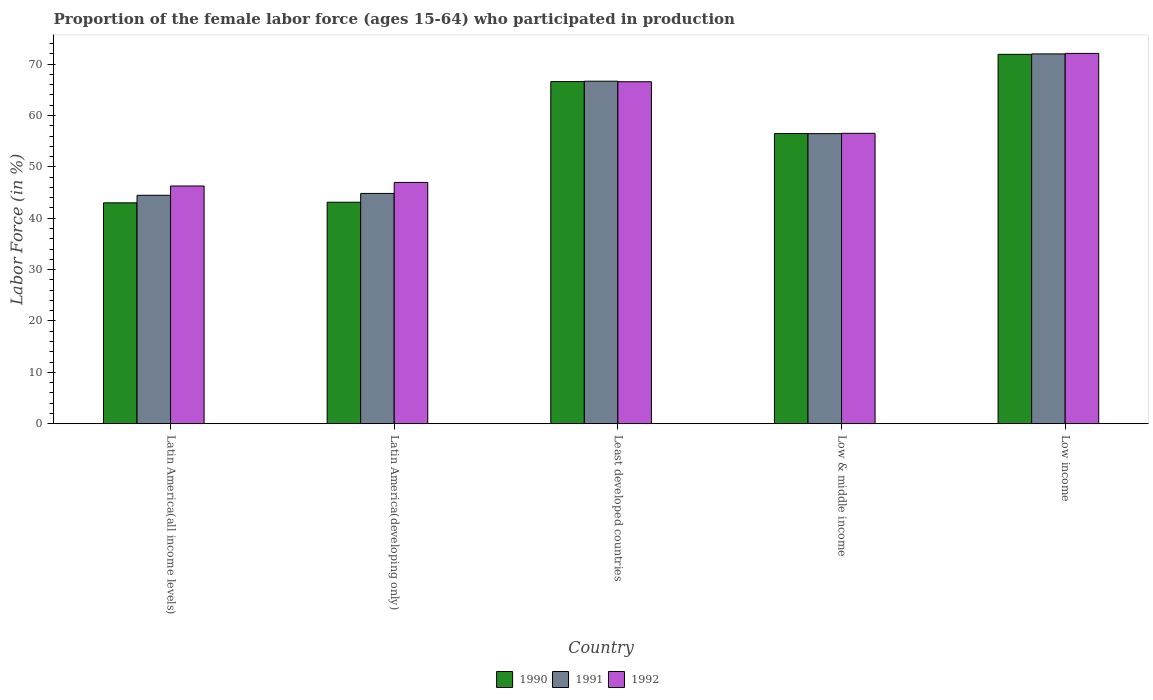How many different coloured bars are there?
Provide a succinct answer. 3. How many bars are there on the 3rd tick from the right?
Give a very brief answer. 3. What is the label of the 1st group of bars from the left?
Your answer should be very brief. Latin America(all income levels). What is the proportion of the female labor force who participated in production in 1991 in Low income?
Your answer should be very brief. 71.99. Across all countries, what is the maximum proportion of the female labor force who participated in production in 1991?
Offer a terse response. 71.99. Across all countries, what is the minimum proportion of the female labor force who participated in production in 1990?
Your answer should be compact. 43. In which country was the proportion of the female labor force who participated in production in 1992 minimum?
Make the answer very short. Latin America(all income levels). What is the total proportion of the female labor force who participated in production in 1991 in the graph?
Your answer should be very brief. 284.44. What is the difference between the proportion of the female labor force who participated in production in 1991 in Least developed countries and that in Low income?
Make the answer very short. -5.31. What is the difference between the proportion of the female labor force who participated in production in 1991 in Latin America(all income levels) and the proportion of the female labor force who participated in production in 1990 in Least developed countries?
Your answer should be very brief. -22.14. What is the average proportion of the female labor force who participated in production in 1990 per country?
Give a very brief answer. 56.22. What is the difference between the proportion of the female labor force who participated in production of/in 1992 and proportion of the female labor force who participated in production of/in 1991 in Least developed countries?
Offer a terse response. -0.1. What is the ratio of the proportion of the female labor force who participated in production in 1992 in Least developed countries to that in Low & middle income?
Provide a succinct answer. 1.18. Is the difference between the proportion of the female labor force who participated in production in 1992 in Latin America(all income levels) and Latin America(developing only) greater than the difference between the proportion of the female labor force who participated in production in 1991 in Latin America(all income levels) and Latin America(developing only)?
Provide a short and direct response. No. What is the difference between the highest and the second highest proportion of the female labor force who participated in production in 1990?
Keep it short and to the point. -10.12. What is the difference between the highest and the lowest proportion of the female labor force who participated in production in 1992?
Make the answer very short. 25.81. Is the sum of the proportion of the female labor force who participated in production in 1992 in Latin America(all income levels) and Least developed countries greater than the maximum proportion of the female labor force who participated in production in 1991 across all countries?
Your response must be concise. Yes. What does the 2nd bar from the right in Low income represents?
Give a very brief answer. 1991. Is it the case that in every country, the sum of the proportion of the female labor force who participated in production in 1992 and proportion of the female labor force who participated in production in 1990 is greater than the proportion of the female labor force who participated in production in 1991?
Provide a short and direct response. Yes. How many bars are there?
Keep it short and to the point. 15. How many countries are there in the graph?
Provide a short and direct response. 5. What is the difference between two consecutive major ticks on the Y-axis?
Your answer should be compact. 10. Does the graph contain any zero values?
Your answer should be compact. No. What is the title of the graph?
Ensure brevity in your answer.  Proportion of the female labor force (ages 15-64) who participated in production. What is the label or title of the X-axis?
Keep it short and to the point. Country. What is the label or title of the Y-axis?
Keep it short and to the point. Labor Force (in %). What is the Labor Force (in %) in 1990 in Latin America(all income levels)?
Provide a short and direct response. 43. What is the Labor Force (in %) of 1991 in Latin America(all income levels)?
Provide a succinct answer. 44.47. What is the Labor Force (in %) of 1992 in Latin America(all income levels)?
Provide a succinct answer. 46.28. What is the Labor Force (in %) of 1990 in Latin America(developing only)?
Offer a very short reply. 43.12. What is the Labor Force (in %) in 1991 in Latin America(developing only)?
Your answer should be compact. 44.83. What is the Labor Force (in %) of 1992 in Latin America(developing only)?
Your response must be concise. 46.97. What is the Labor Force (in %) of 1990 in Least developed countries?
Make the answer very short. 66.61. What is the Labor Force (in %) of 1991 in Least developed countries?
Offer a very short reply. 66.68. What is the Labor Force (in %) in 1992 in Least developed countries?
Provide a short and direct response. 66.57. What is the Labor Force (in %) of 1990 in Low & middle income?
Your answer should be very brief. 56.48. What is the Labor Force (in %) in 1991 in Low & middle income?
Your response must be concise. 56.47. What is the Labor Force (in %) in 1992 in Low & middle income?
Ensure brevity in your answer.  56.53. What is the Labor Force (in %) of 1990 in Low income?
Provide a short and direct response. 71.9. What is the Labor Force (in %) in 1991 in Low income?
Provide a succinct answer. 71.99. What is the Labor Force (in %) of 1992 in Low income?
Your response must be concise. 72.09. Across all countries, what is the maximum Labor Force (in %) in 1990?
Make the answer very short. 71.9. Across all countries, what is the maximum Labor Force (in %) in 1991?
Offer a very short reply. 71.99. Across all countries, what is the maximum Labor Force (in %) in 1992?
Your answer should be very brief. 72.09. Across all countries, what is the minimum Labor Force (in %) of 1990?
Give a very brief answer. 43. Across all countries, what is the minimum Labor Force (in %) of 1991?
Give a very brief answer. 44.47. Across all countries, what is the minimum Labor Force (in %) in 1992?
Your answer should be very brief. 46.28. What is the total Labor Force (in %) in 1990 in the graph?
Make the answer very short. 281.12. What is the total Labor Force (in %) in 1991 in the graph?
Provide a short and direct response. 284.44. What is the total Labor Force (in %) of 1992 in the graph?
Provide a succinct answer. 288.44. What is the difference between the Labor Force (in %) of 1990 in Latin America(all income levels) and that in Latin America(developing only)?
Keep it short and to the point. -0.12. What is the difference between the Labor Force (in %) of 1991 in Latin America(all income levels) and that in Latin America(developing only)?
Your response must be concise. -0.36. What is the difference between the Labor Force (in %) of 1992 in Latin America(all income levels) and that in Latin America(developing only)?
Keep it short and to the point. -0.69. What is the difference between the Labor Force (in %) of 1990 in Latin America(all income levels) and that in Least developed countries?
Offer a very short reply. -23.61. What is the difference between the Labor Force (in %) of 1991 in Latin America(all income levels) and that in Least developed countries?
Ensure brevity in your answer.  -22.21. What is the difference between the Labor Force (in %) of 1992 in Latin America(all income levels) and that in Least developed countries?
Give a very brief answer. -20.29. What is the difference between the Labor Force (in %) in 1990 in Latin America(all income levels) and that in Low & middle income?
Your answer should be compact. -13.48. What is the difference between the Labor Force (in %) of 1991 in Latin America(all income levels) and that in Low & middle income?
Provide a succinct answer. -12. What is the difference between the Labor Force (in %) of 1992 in Latin America(all income levels) and that in Low & middle income?
Offer a terse response. -10.25. What is the difference between the Labor Force (in %) of 1990 in Latin America(all income levels) and that in Low income?
Keep it short and to the point. -28.9. What is the difference between the Labor Force (in %) in 1991 in Latin America(all income levels) and that in Low income?
Offer a terse response. -27.52. What is the difference between the Labor Force (in %) in 1992 in Latin America(all income levels) and that in Low income?
Provide a succinct answer. -25.81. What is the difference between the Labor Force (in %) in 1990 in Latin America(developing only) and that in Least developed countries?
Your answer should be very brief. -23.49. What is the difference between the Labor Force (in %) in 1991 in Latin America(developing only) and that in Least developed countries?
Keep it short and to the point. -21.85. What is the difference between the Labor Force (in %) in 1992 in Latin America(developing only) and that in Least developed countries?
Provide a short and direct response. -19.6. What is the difference between the Labor Force (in %) of 1990 in Latin America(developing only) and that in Low & middle income?
Offer a terse response. -13.36. What is the difference between the Labor Force (in %) of 1991 in Latin America(developing only) and that in Low & middle income?
Offer a very short reply. -11.64. What is the difference between the Labor Force (in %) in 1992 in Latin America(developing only) and that in Low & middle income?
Offer a very short reply. -9.56. What is the difference between the Labor Force (in %) in 1990 in Latin America(developing only) and that in Low income?
Give a very brief answer. -28.78. What is the difference between the Labor Force (in %) in 1991 in Latin America(developing only) and that in Low income?
Your answer should be very brief. -27.16. What is the difference between the Labor Force (in %) in 1992 in Latin America(developing only) and that in Low income?
Ensure brevity in your answer.  -25.12. What is the difference between the Labor Force (in %) of 1990 in Least developed countries and that in Low & middle income?
Give a very brief answer. 10.12. What is the difference between the Labor Force (in %) of 1991 in Least developed countries and that in Low & middle income?
Keep it short and to the point. 10.21. What is the difference between the Labor Force (in %) in 1992 in Least developed countries and that in Low & middle income?
Give a very brief answer. 10.04. What is the difference between the Labor Force (in %) in 1990 in Least developed countries and that in Low income?
Make the answer very short. -5.3. What is the difference between the Labor Force (in %) of 1991 in Least developed countries and that in Low income?
Provide a succinct answer. -5.31. What is the difference between the Labor Force (in %) in 1992 in Least developed countries and that in Low income?
Your answer should be compact. -5.52. What is the difference between the Labor Force (in %) of 1990 in Low & middle income and that in Low income?
Your response must be concise. -15.42. What is the difference between the Labor Force (in %) of 1991 in Low & middle income and that in Low income?
Offer a very short reply. -15.52. What is the difference between the Labor Force (in %) in 1992 in Low & middle income and that in Low income?
Your response must be concise. -15.56. What is the difference between the Labor Force (in %) of 1990 in Latin America(all income levels) and the Labor Force (in %) of 1991 in Latin America(developing only)?
Your answer should be compact. -1.83. What is the difference between the Labor Force (in %) of 1990 in Latin America(all income levels) and the Labor Force (in %) of 1992 in Latin America(developing only)?
Offer a terse response. -3.97. What is the difference between the Labor Force (in %) in 1991 in Latin America(all income levels) and the Labor Force (in %) in 1992 in Latin America(developing only)?
Make the answer very short. -2.5. What is the difference between the Labor Force (in %) in 1990 in Latin America(all income levels) and the Labor Force (in %) in 1991 in Least developed countries?
Provide a succinct answer. -23.68. What is the difference between the Labor Force (in %) in 1990 in Latin America(all income levels) and the Labor Force (in %) in 1992 in Least developed countries?
Your response must be concise. -23.57. What is the difference between the Labor Force (in %) in 1991 in Latin America(all income levels) and the Labor Force (in %) in 1992 in Least developed countries?
Provide a succinct answer. -22.1. What is the difference between the Labor Force (in %) of 1990 in Latin America(all income levels) and the Labor Force (in %) of 1991 in Low & middle income?
Provide a short and direct response. -13.47. What is the difference between the Labor Force (in %) of 1990 in Latin America(all income levels) and the Labor Force (in %) of 1992 in Low & middle income?
Your answer should be very brief. -13.53. What is the difference between the Labor Force (in %) of 1991 in Latin America(all income levels) and the Labor Force (in %) of 1992 in Low & middle income?
Give a very brief answer. -12.06. What is the difference between the Labor Force (in %) of 1990 in Latin America(all income levels) and the Labor Force (in %) of 1991 in Low income?
Your response must be concise. -28.99. What is the difference between the Labor Force (in %) in 1990 in Latin America(all income levels) and the Labor Force (in %) in 1992 in Low income?
Provide a succinct answer. -29.09. What is the difference between the Labor Force (in %) of 1991 in Latin America(all income levels) and the Labor Force (in %) of 1992 in Low income?
Give a very brief answer. -27.62. What is the difference between the Labor Force (in %) in 1990 in Latin America(developing only) and the Labor Force (in %) in 1991 in Least developed countries?
Give a very brief answer. -23.56. What is the difference between the Labor Force (in %) in 1990 in Latin America(developing only) and the Labor Force (in %) in 1992 in Least developed countries?
Provide a short and direct response. -23.45. What is the difference between the Labor Force (in %) in 1991 in Latin America(developing only) and the Labor Force (in %) in 1992 in Least developed countries?
Your answer should be compact. -21.74. What is the difference between the Labor Force (in %) of 1990 in Latin America(developing only) and the Labor Force (in %) of 1991 in Low & middle income?
Your answer should be very brief. -13.35. What is the difference between the Labor Force (in %) of 1990 in Latin America(developing only) and the Labor Force (in %) of 1992 in Low & middle income?
Your answer should be compact. -13.41. What is the difference between the Labor Force (in %) of 1991 in Latin America(developing only) and the Labor Force (in %) of 1992 in Low & middle income?
Your answer should be very brief. -11.7. What is the difference between the Labor Force (in %) in 1990 in Latin America(developing only) and the Labor Force (in %) in 1991 in Low income?
Your response must be concise. -28.87. What is the difference between the Labor Force (in %) of 1990 in Latin America(developing only) and the Labor Force (in %) of 1992 in Low income?
Provide a succinct answer. -28.97. What is the difference between the Labor Force (in %) of 1991 in Latin America(developing only) and the Labor Force (in %) of 1992 in Low income?
Provide a succinct answer. -27.26. What is the difference between the Labor Force (in %) in 1990 in Least developed countries and the Labor Force (in %) in 1991 in Low & middle income?
Keep it short and to the point. 10.14. What is the difference between the Labor Force (in %) in 1990 in Least developed countries and the Labor Force (in %) in 1992 in Low & middle income?
Offer a very short reply. 10.08. What is the difference between the Labor Force (in %) of 1991 in Least developed countries and the Labor Force (in %) of 1992 in Low & middle income?
Your answer should be compact. 10.15. What is the difference between the Labor Force (in %) of 1990 in Least developed countries and the Labor Force (in %) of 1991 in Low income?
Your answer should be very brief. -5.38. What is the difference between the Labor Force (in %) in 1990 in Least developed countries and the Labor Force (in %) in 1992 in Low income?
Your answer should be very brief. -5.48. What is the difference between the Labor Force (in %) in 1991 in Least developed countries and the Labor Force (in %) in 1992 in Low income?
Keep it short and to the point. -5.41. What is the difference between the Labor Force (in %) in 1990 in Low & middle income and the Labor Force (in %) in 1991 in Low income?
Offer a terse response. -15.51. What is the difference between the Labor Force (in %) in 1990 in Low & middle income and the Labor Force (in %) in 1992 in Low income?
Provide a succinct answer. -15.61. What is the difference between the Labor Force (in %) in 1991 in Low & middle income and the Labor Force (in %) in 1992 in Low income?
Offer a terse response. -15.62. What is the average Labor Force (in %) of 1990 per country?
Make the answer very short. 56.22. What is the average Labor Force (in %) of 1991 per country?
Your answer should be very brief. 56.89. What is the average Labor Force (in %) of 1992 per country?
Your answer should be very brief. 57.69. What is the difference between the Labor Force (in %) in 1990 and Labor Force (in %) in 1991 in Latin America(all income levels)?
Your answer should be compact. -1.47. What is the difference between the Labor Force (in %) of 1990 and Labor Force (in %) of 1992 in Latin America(all income levels)?
Make the answer very short. -3.28. What is the difference between the Labor Force (in %) of 1991 and Labor Force (in %) of 1992 in Latin America(all income levels)?
Offer a very short reply. -1.81. What is the difference between the Labor Force (in %) of 1990 and Labor Force (in %) of 1991 in Latin America(developing only)?
Give a very brief answer. -1.71. What is the difference between the Labor Force (in %) in 1990 and Labor Force (in %) in 1992 in Latin America(developing only)?
Ensure brevity in your answer.  -3.85. What is the difference between the Labor Force (in %) of 1991 and Labor Force (in %) of 1992 in Latin America(developing only)?
Keep it short and to the point. -2.14. What is the difference between the Labor Force (in %) in 1990 and Labor Force (in %) in 1991 in Least developed countries?
Your answer should be very brief. -0.07. What is the difference between the Labor Force (in %) in 1990 and Labor Force (in %) in 1992 in Least developed countries?
Offer a very short reply. 0.03. What is the difference between the Labor Force (in %) in 1991 and Labor Force (in %) in 1992 in Least developed countries?
Ensure brevity in your answer.  0.1. What is the difference between the Labor Force (in %) in 1990 and Labor Force (in %) in 1991 in Low & middle income?
Give a very brief answer. 0.01. What is the difference between the Labor Force (in %) in 1990 and Labor Force (in %) in 1992 in Low & middle income?
Your answer should be very brief. -0.05. What is the difference between the Labor Force (in %) in 1991 and Labor Force (in %) in 1992 in Low & middle income?
Provide a succinct answer. -0.06. What is the difference between the Labor Force (in %) in 1990 and Labor Force (in %) in 1991 in Low income?
Offer a terse response. -0.09. What is the difference between the Labor Force (in %) in 1990 and Labor Force (in %) in 1992 in Low income?
Ensure brevity in your answer.  -0.18. What is the difference between the Labor Force (in %) in 1991 and Labor Force (in %) in 1992 in Low income?
Your response must be concise. -0.1. What is the ratio of the Labor Force (in %) of 1991 in Latin America(all income levels) to that in Latin America(developing only)?
Provide a succinct answer. 0.99. What is the ratio of the Labor Force (in %) of 1992 in Latin America(all income levels) to that in Latin America(developing only)?
Make the answer very short. 0.99. What is the ratio of the Labor Force (in %) in 1990 in Latin America(all income levels) to that in Least developed countries?
Offer a very short reply. 0.65. What is the ratio of the Labor Force (in %) in 1991 in Latin America(all income levels) to that in Least developed countries?
Give a very brief answer. 0.67. What is the ratio of the Labor Force (in %) of 1992 in Latin America(all income levels) to that in Least developed countries?
Make the answer very short. 0.7. What is the ratio of the Labor Force (in %) in 1990 in Latin America(all income levels) to that in Low & middle income?
Make the answer very short. 0.76. What is the ratio of the Labor Force (in %) of 1991 in Latin America(all income levels) to that in Low & middle income?
Provide a short and direct response. 0.79. What is the ratio of the Labor Force (in %) of 1992 in Latin America(all income levels) to that in Low & middle income?
Provide a short and direct response. 0.82. What is the ratio of the Labor Force (in %) of 1990 in Latin America(all income levels) to that in Low income?
Keep it short and to the point. 0.6. What is the ratio of the Labor Force (in %) in 1991 in Latin America(all income levels) to that in Low income?
Your response must be concise. 0.62. What is the ratio of the Labor Force (in %) of 1992 in Latin America(all income levels) to that in Low income?
Your answer should be compact. 0.64. What is the ratio of the Labor Force (in %) in 1990 in Latin America(developing only) to that in Least developed countries?
Offer a terse response. 0.65. What is the ratio of the Labor Force (in %) of 1991 in Latin America(developing only) to that in Least developed countries?
Your answer should be very brief. 0.67. What is the ratio of the Labor Force (in %) of 1992 in Latin America(developing only) to that in Least developed countries?
Provide a succinct answer. 0.71. What is the ratio of the Labor Force (in %) of 1990 in Latin America(developing only) to that in Low & middle income?
Offer a very short reply. 0.76. What is the ratio of the Labor Force (in %) in 1991 in Latin America(developing only) to that in Low & middle income?
Offer a very short reply. 0.79. What is the ratio of the Labor Force (in %) of 1992 in Latin America(developing only) to that in Low & middle income?
Your answer should be compact. 0.83. What is the ratio of the Labor Force (in %) of 1990 in Latin America(developing only) to that in Low income?
Provide a short and direct response. 0.6. What is the ratio of the Labor Force (in %) in 1991 in Latin America(developing only) to that in Low income?
Keep it short and to the point. 0.62. What is the ratio of the Labor Force (in %) in 1992 in Latin America(developing only) to that in Low income?
Your response must be concise. 0.65. What is the ratio of the Labor Force (in %) of 1990 in Least developed countries to that in Low & middle income?
Offer a very short reply. 1.18. What is the ratio of the Labor Force (in %) of 1991 in Least developed countries to that in Low & middle income?
Provide a succinct answer. 1.18. What is the ratio of the Labor Force (in %) of 1992 in Least developed countries to that in Low & middle income?
Provide a short and direct response. 1.18. What is the ratio of the Labor Force (in %) of 1990 in Least developed countries to that in Low income?
Ensure brevity in your answer.  0.93. What is the ratio of the Labor Force (in %) in 1991 in Least developed countries to that in Low income?
Keep it short and to the point. 0.93. What is the ratio of the Labor Force (in %) of 1992 in Least developed countries to that in Low income?
Offer a very short reply. 0.92. What is the ratio of the Labor Force (in %) of 1990 in Low & middle income to that in Low income?
Your answer should be very brief. 0.79. What is the ratio of the Labor Force (in %) in 1991 in Low & middle income to that in Low income?
Provide a succinct answer. 0.78. What is the ratio of the Labor Force (in %) in 1992 in Low & middle income to that in Low income?
Keep it short and to the point. 0.78. What is the difference between the highest and the second highest Labor Force (in %) of 1990?
Make the answer very short. 5.3. What is the difference between the highest and the second highest Labor Force (in %) of 1991?
Your response must be concise. 5.31. What is the difference between the highest and the second highest Labor Force (in %) of 1992?
Offer a terse response. 5.52. What is the difference between the highest and the lowest Labor Force (in %) of 1990?
Offer a very short reply. 28.9. What is the difference between the highest and the lowest Labor Force (in %) of 1991?
Keep it short and to the point. 27.52. What is the difference between the highest and the lowest Labor Force (in %) of 1992?
Offer a terse response. 25.81. 